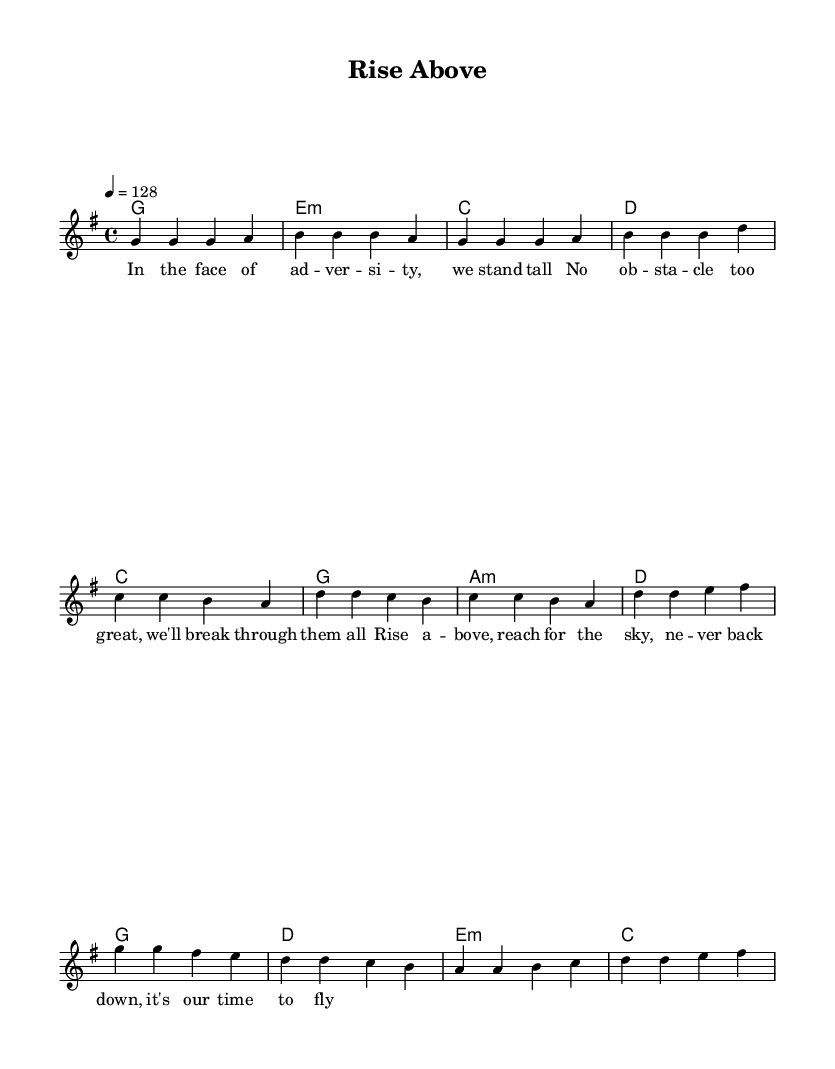What is the key signature of this music? The key signature shows one sharp, which indicates that the key is G major.
Answer: G major What is the time signature of this music? The time signature is indicated by the '4/4' in the score, meaning there are four beats per measure.
Answer: 4/4 What is the tempo marking of this piece? The tempo marking is set to a quarter note equals 128 beats per minute, which is indicated directly in the score as "4 = 128".
Answer: 128 How many measures are in the chorus section? By counting the measures beneath the chorus lyrics, there are four distinct measures present in this section.
Answer: 4 What is the first note of the pre-chorus? The first note of the pre-chorus section is C, as indicated by the first note on the staff following the pre-chorus lyrics.
Answer: C How does the harmony change between the verse and the chorus? The harmony during the verse uses G, E minor, C, and D, while the chorus shifts to G, D, E minor, and C, demonstrating a change in chord progression.
Answer: Changes from G, E minor, C, D to G, D, E minor, C What lyrical theme is presented in the chorus? The chorus expresses a motivational theme about rising above challenges and reaching for one's goals, as described by the lyrics.
Answer: Motivational theme 